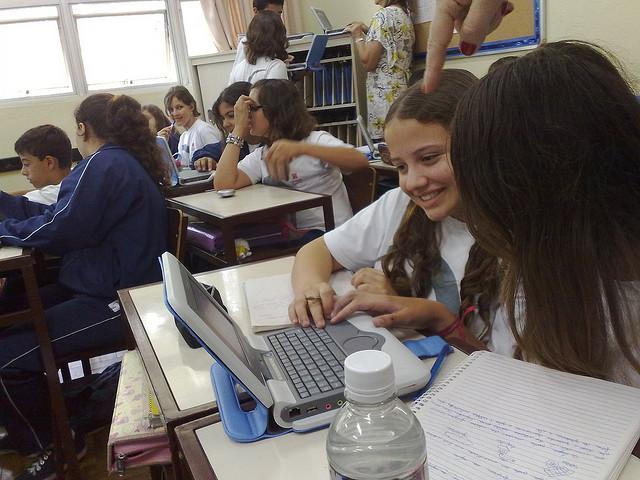How many people are in the photo?
Give a very brief answer. 9. How many bottles can be seen?
Give a very brief answer. 1. How many chairs can be seen?
Give a very brief answer. 2. How many giraffe are there?
Give a very brief answer. 0. 